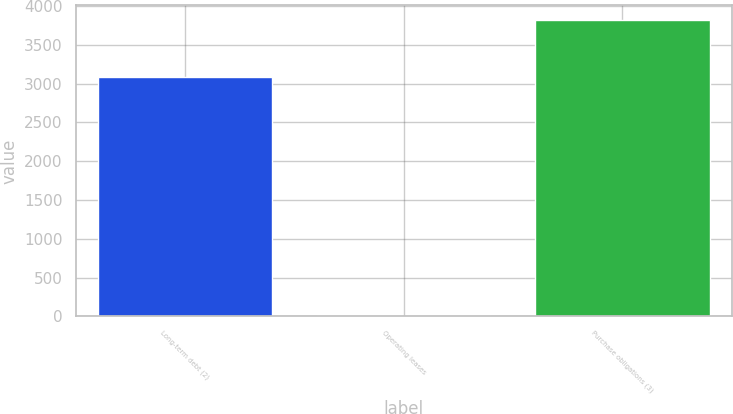Convert chart to OTSL. <chart><loc_0><loc_0><loc_500><loc_500><bar_chart><fcel>Long-term debt (2)<fcel>Operating leases<fcel>Purchase obligations (3)<nl><fcel>3084<fcel>2<fcel>3820<nl></chart> 